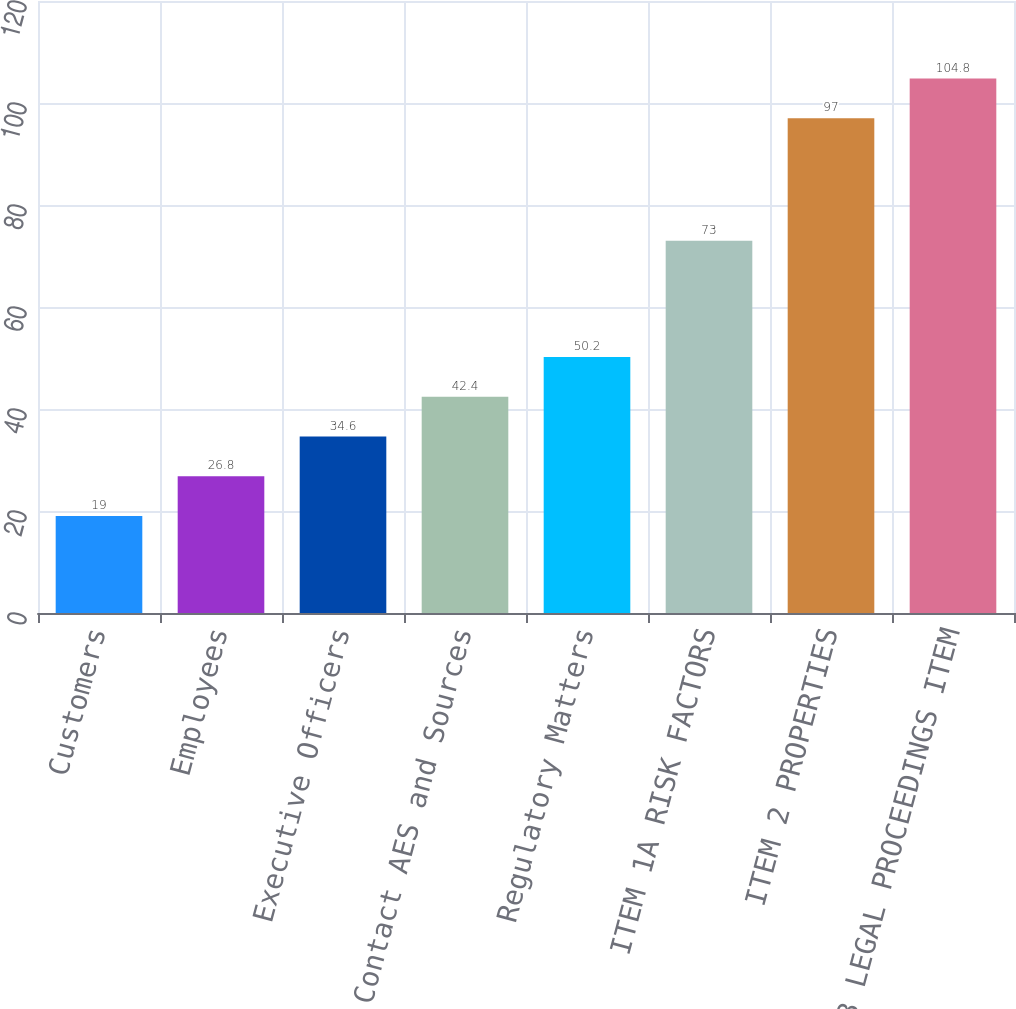Convert chart. <chart><loc_0><loc_0><loc_500><loc_500><bar_chart><fcel>Customers<fcel>Employees<fcel>Executive Officers<fcel>How to Contact AES and Sources<fcel>Regulatory Matters<fcel>ITEM 1A RISK FACTORS<fcel>ITEM 2 PROPERTIES<fcel>ITEM 3 LEGAL PROCEEDINGS ITEM<nl><fcel>19<fcel>26.8<fcel>34.6<fcel>42.4<fcel>50.2<fcel>73<fcel>97<fcel>104.8<nl></chart> 